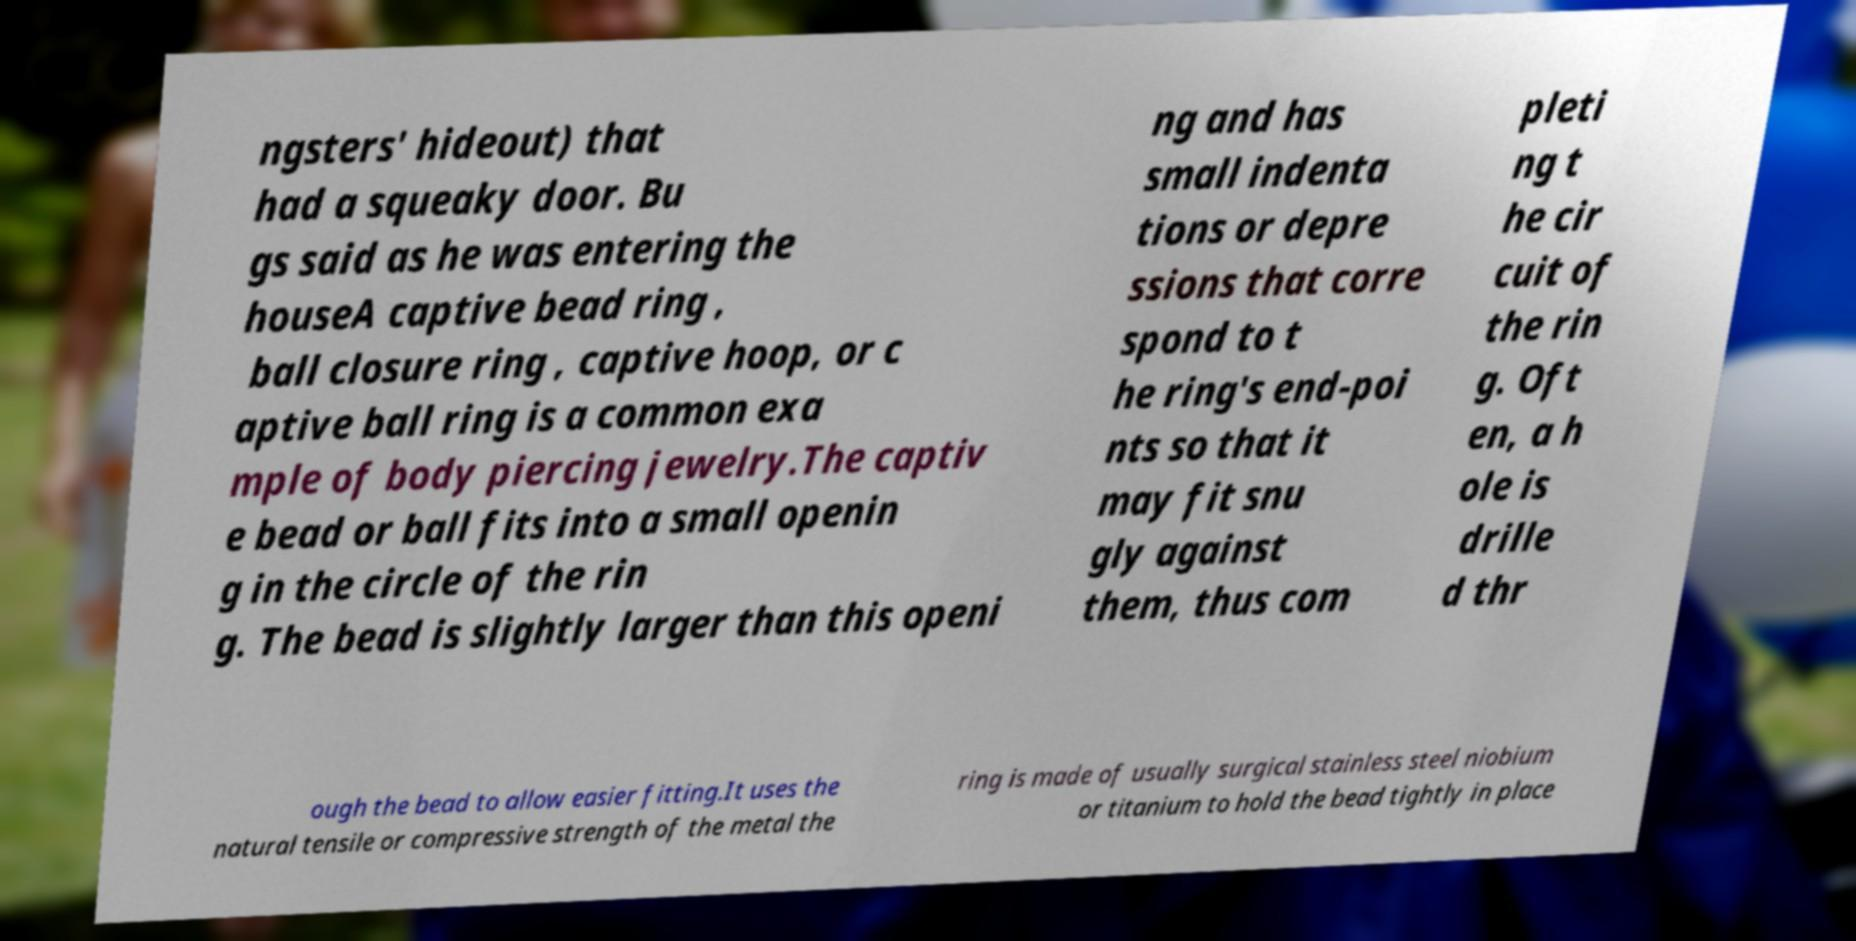Please read and relay the text visible in this image. What does it say? ngsters' hideout) that had a squeaky door. Bu gs said as he was entering the houseA captive bead ring , ball closure ring , captive hoop, or c aptive ball ring is a common exa mple of body piercing jewelry.The captiv e bead or ball fits into a small openin g in the circle of the rin g. The bead is slightly larger than this openi ng and has small indenta tions or depre ssions that corre spond to t he ring's end-poi nts so that it may fit snu gly against them, thus com pleti ng t he cir cuit of the rin g. Oft en, a h ole is drille d thr ough the bead to allow easier fitting.It uses the natural tensile or compressive strength of the metal the ring is made of usually surgical stainless steel niobium or titanium to hold the bead tightly in place 